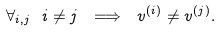Convert formula to latex. <formula><loc_0><loc_0><loc_500><loc_500>\forall _ { i , j } \ i \ne j \ \Longrightarrow \ v ^ { ( i ) } \ne v ^ { ( j ) } .</formula> 